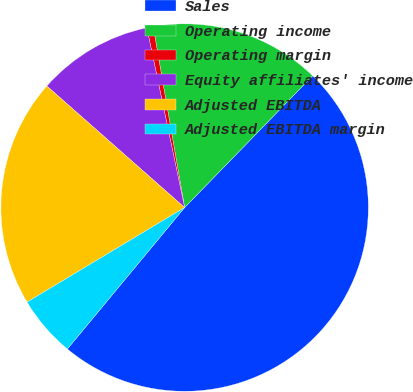<chart> <loc_0><loc_0><loc_500><loc_500><pie_chart><fcel>Sales<fcel>Operating income<fcel>Operating margin<fcel>Equity affiliates' income<fcel>Adjusted EBITDA<fcel>Adjusted EBITDA margin<nl><fcel>48.75%<fcel>15.01%<fcel>0.56%<fcel>10.2%<fcel>20.11%<fcel>5.38%<nl></chart> 